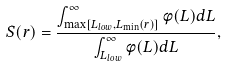Convert formula to latex. <formula><loc_0><loc_0><loc_500><loc_500>S ( r ) = \frac { \int _ { \max [ L _ { l o w } , L _ { \min } ( r ) ] } ^ { \infty } \phi ( L ) d L } { \int _ { L _ { l o w } } ^ { \infty } \phi ( L ) d L } ,</formula> 